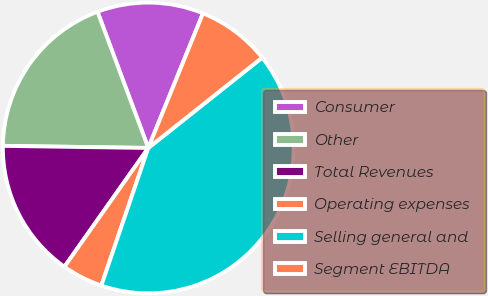Convert chart. <chart><loc_0><loc_0><loc_500><loc_500><pie_chart><fcel>Consumer<fcel>Other<fcel>Total Revenues<fcel>Operating expenses<fcel>Selling general and<fcel>Segment EBITDA<nl><fcel>11.82%<fcel>19.09%<fcel>15.45%<fcel>4.55%<fcel>40.91%<fcel>8.18%<nl></chart> 